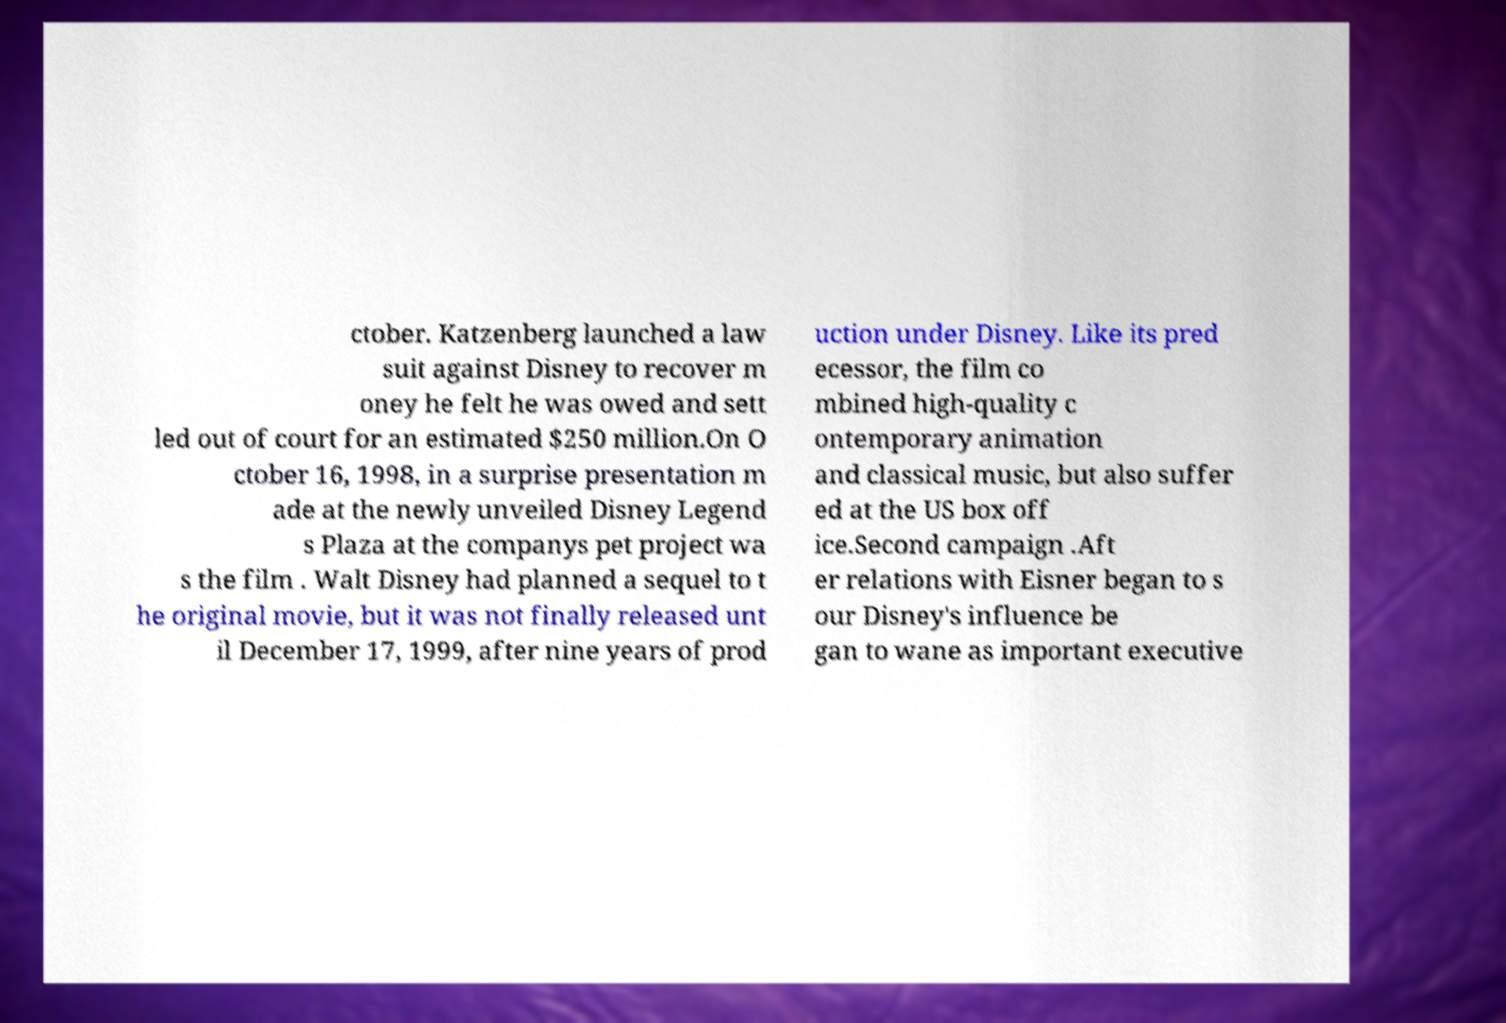What messages or text are displayed in this image? I need them in a readable, typed format. ctober. Katzenberg launched a law suit against Disney to recover m oney he felt he was owed and sett led out of court for an estimated $250 million.On O ctober 16, 1998, in a surprise presentation m ade at the newly unveiled Disney Legend s Plaza at the companys pet project wa s the film . Walt Disney had planned a sequel to t he original movie, but it was not finally released unt il December 17, 1999, after nine years of prod uction under Disney. Like its pred ecessor, the film co mbined high-quality c ontemporary animation and classical music, but also suffer ed at the US box off ice.Second campaign .Aft er relations with Eisner began to s our Disney's influence be gan to wane as important executive 